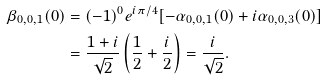<formula> <loc_0><loc_0><loc_500><loc_500>\beta _ { 0 , 0 , 1 } ( 0 ) & = ( - 1 ) ^ { 0 } e ^ { i \pi / 4 } [ - \alpha _ { 0 , 0 , 1 } ( 0 ) + i \alpha _ { 0 , 0 , 3 } ( 0 ) ] \\ & = \frac { 1 + i } { \sqrt { 2 } } \left ( \frac { 1 } { 2 } + \frac { i } { 2 } \right ) = \frac { i } { \sqrt { 2 } } .</formula> 